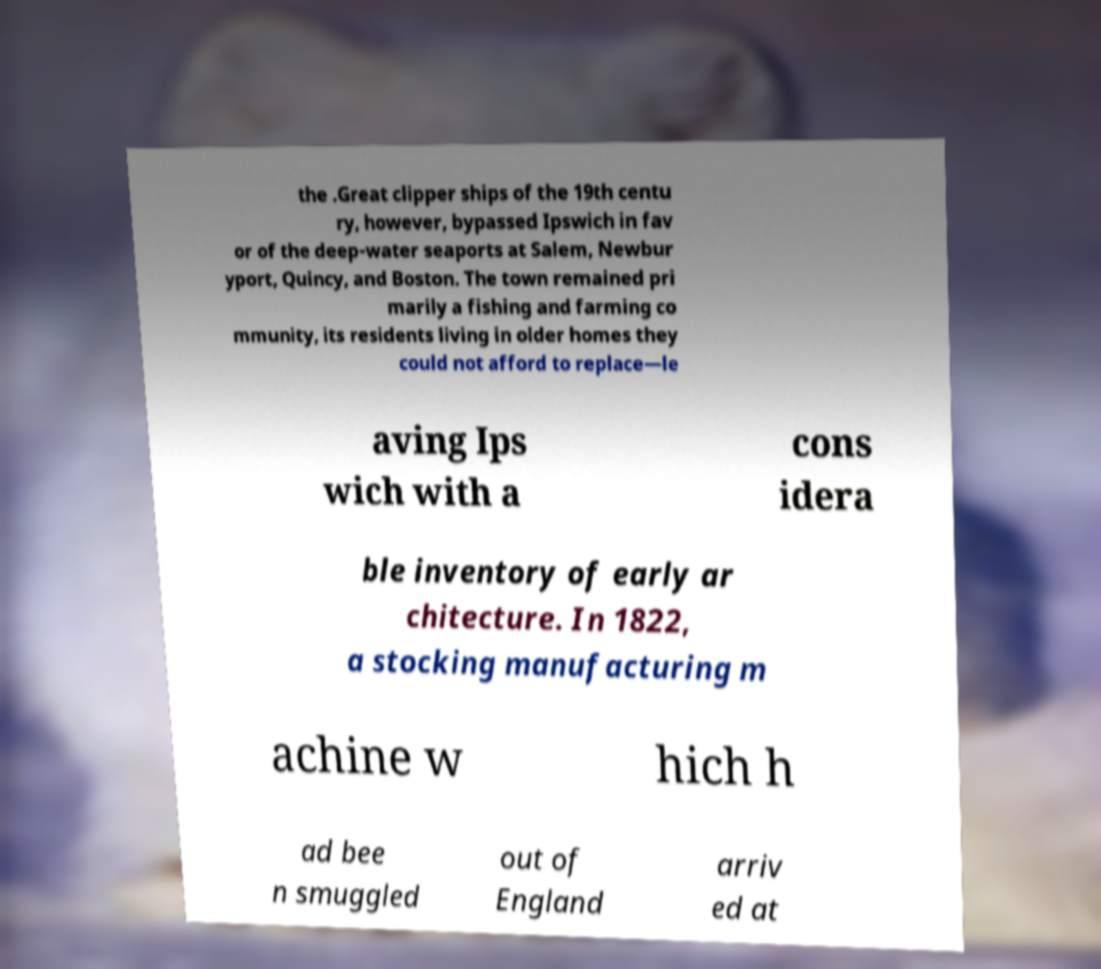For documentation purposes, I need the text within this image transcribed. Could you provide that? the .Great clipper ships of the 19th centu ry, however, bypassed Ipswich in fav or of the deep-water seaports at Salem, Newbur yport, Quincy, and Boston. The town remained pri marily a fishing and farming co mmunity, its residents living in older homes they could not afford to replace—le aving Ips wich with a cons idera ble inventory of early ar chitecture. In 1822, a stocking manufacturing m achine w hich h ad bee n smuggled out of England arriv ed at 